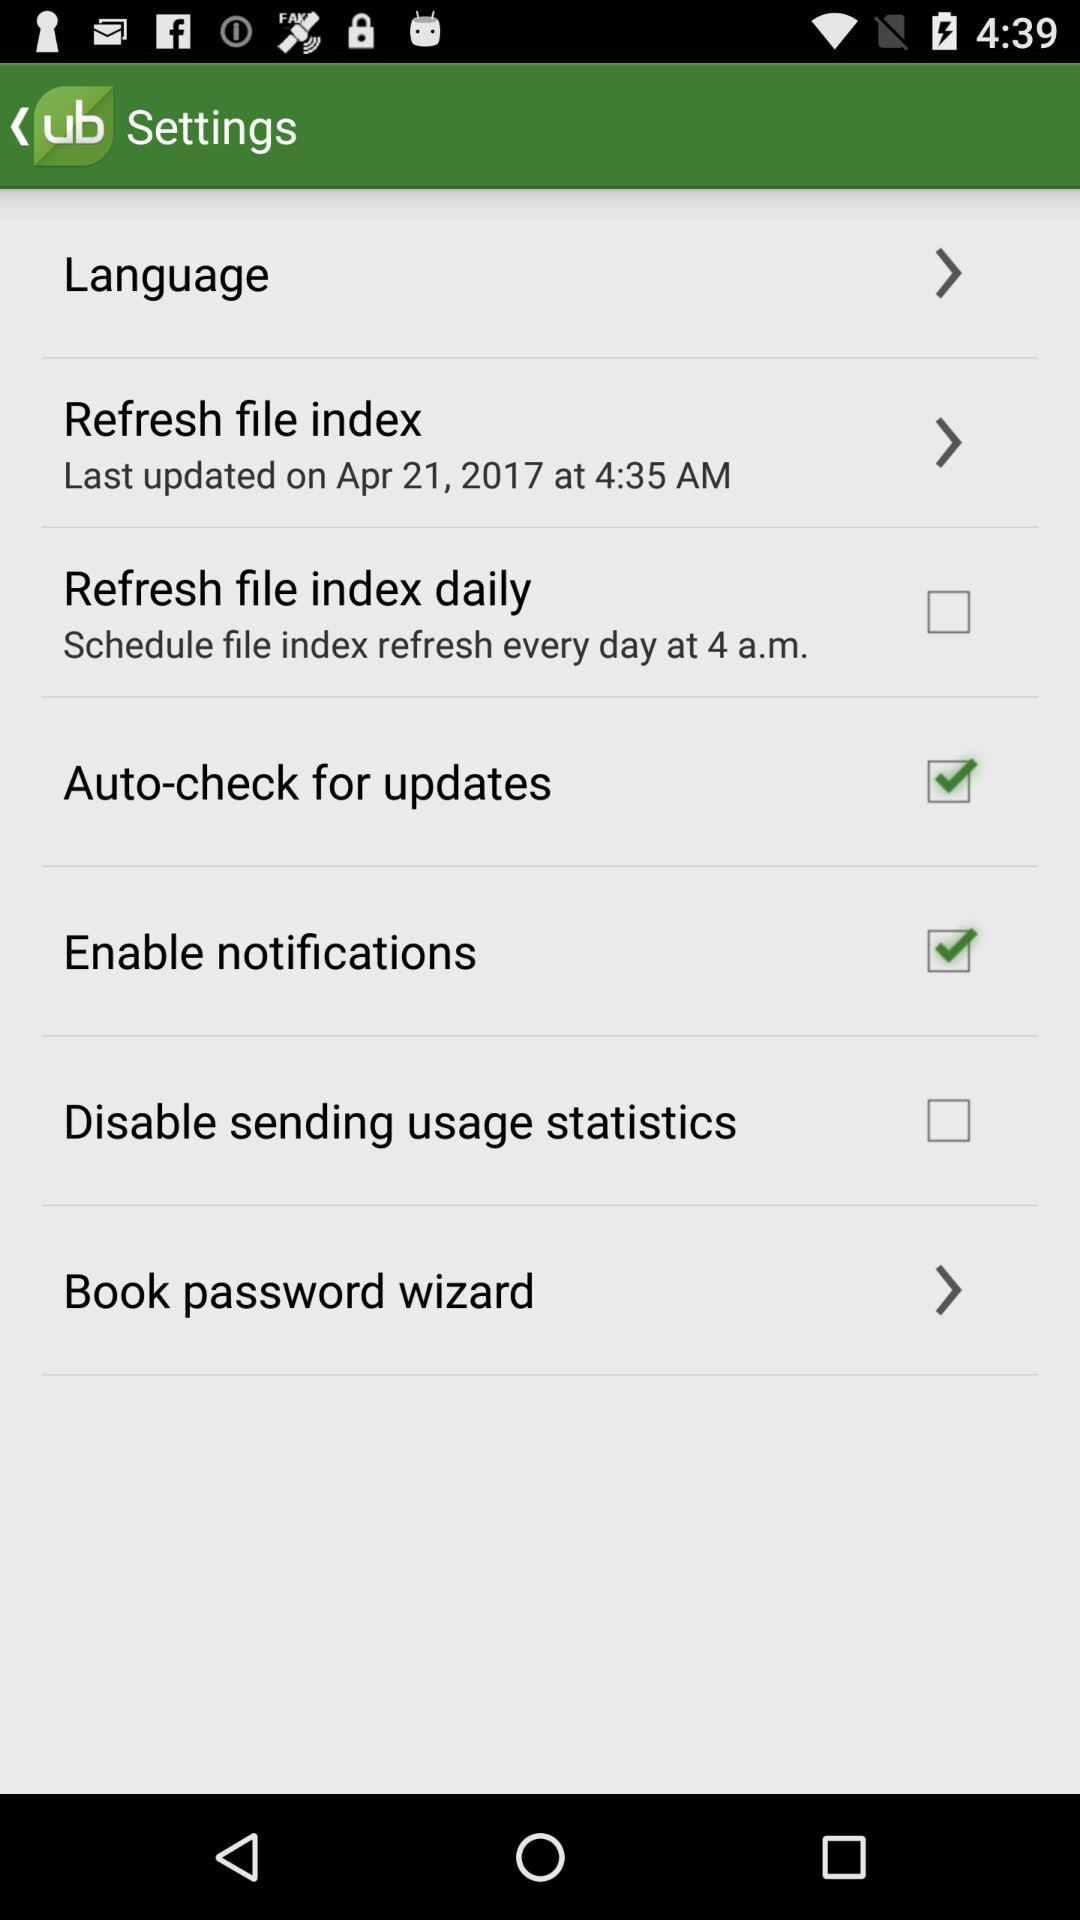Which options are checked? The checked options are "Auto-check for updates" and "Enable notifications". 